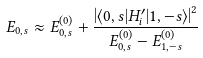<formula> <loc_0><loc_0><loc_500><loc_500>E _ { 0 , s } \approx E ^ { ( 0 ) } _ { 0 , s } + \frac { \left | \langle 0 , s | H ^ { \prime } _ { i } | 1 , - s \rangle \right | ^ { 2 } } { E ^ { ( 0 ) } _ { 0 , s } - E ^ { ( 0 ) } _ { 1 , - s } }</formula> 